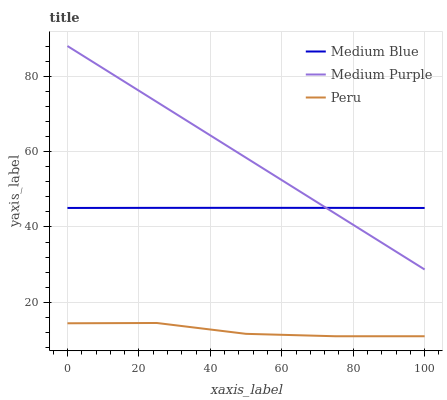Does Peru have the minimum area under the curve?
Answer yes or no. Yes. Does Medium Purple have the maximum area under the curve?
Answer yes or no. Yes. Does Medium Blue have the minimum area under the curve?
Answer yes or no. No. Does Medium Blue have the maximum area under the curve?
Answer yes or no. No. Is Medium Purple the smoothest?
Answer yes or no. Yes. Is Peru the roughest?
Answer yes or no. Yes. Is Medium Blue the smoothest?
Answer yes or no. No. Is Medium Blue the roughest?
Answer yes or no. No. Does Peru have the lowest value?
Answer yes or no. Yes. Does Medium Blue have the lowest value?
Answer yes or no. No. Does Medium Purple have the highest value?
Answer yes or no. Yes. Does Medium Blue have the highest value?
Answer yes or no. No. Is Peru less than Medium Purple?
Answer yes or no. Yes. Is Medium Purple greater than Peru?
Answer yes or no. Yes. Does Medium Blue intersect Medium Purple?
Answer yes or no. Yes. Is Medium Blue less than Medium Purple?
Answer yes or no. No. Is Medium Blue greater than Medium Purple?
Answer yes or no. No. Does Peru intersect Medium Purple?
Answer yes or no. No. 